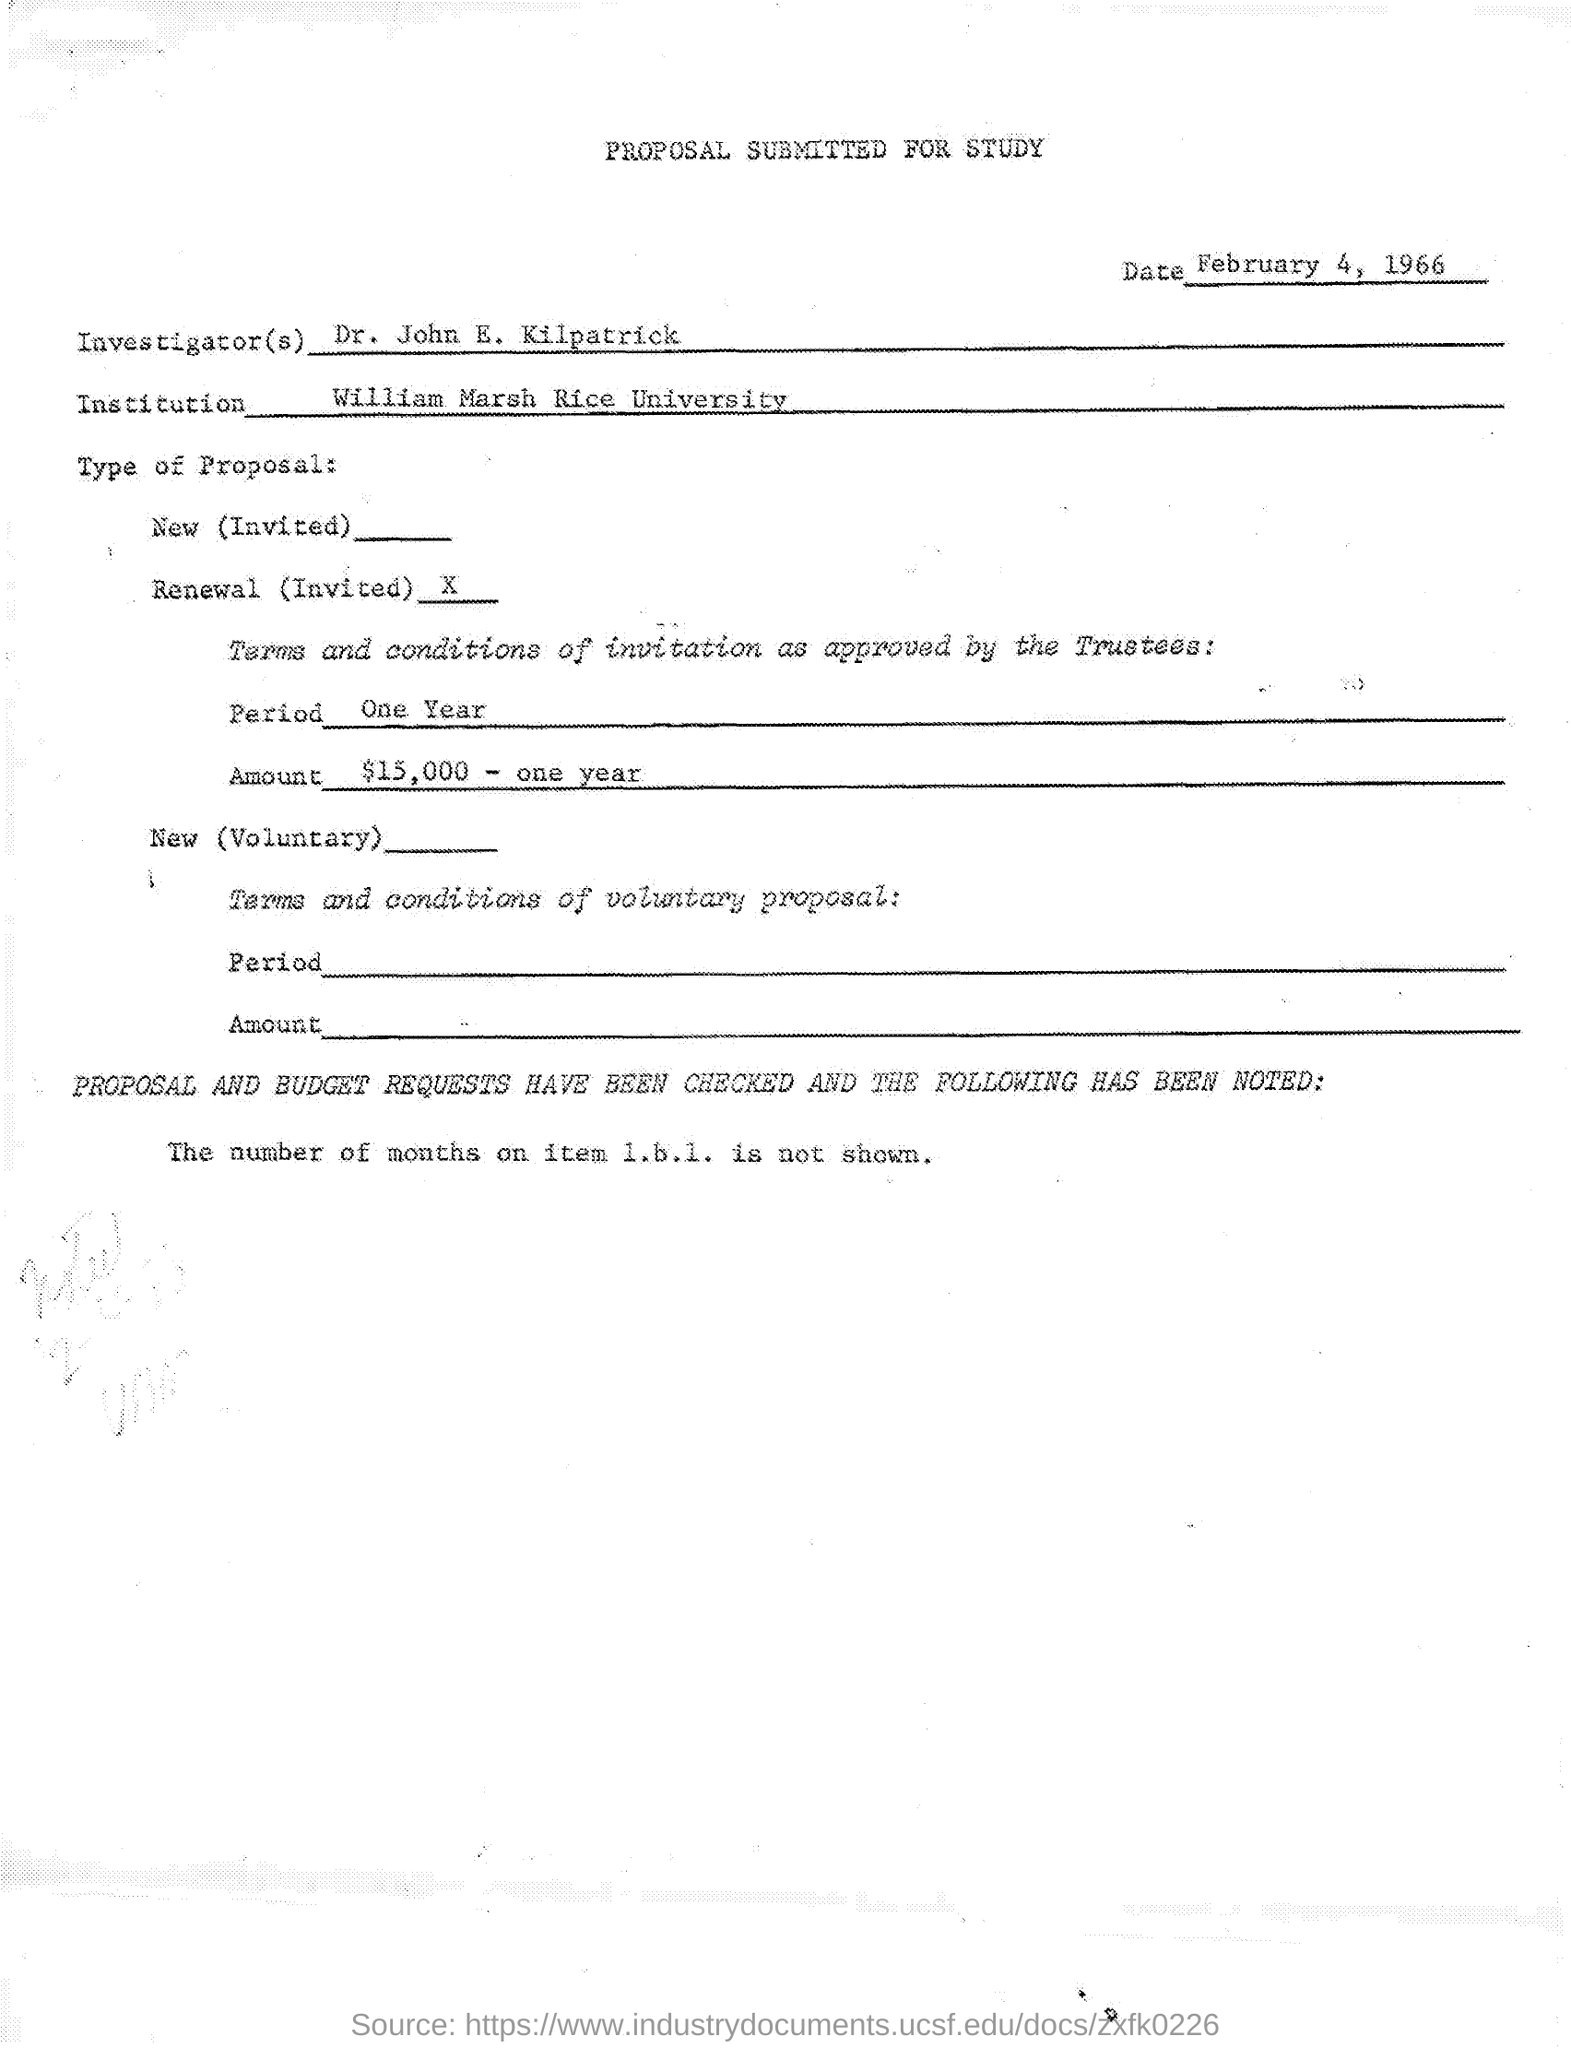What is the Date?
Ensure brevity in your answer.  February 4, 1966. Who is the Investigator?
Your answer should be very brief. Dr. John E. Kilpatrick. What is the Institution?
Your answer should be compact. William Marsh rice University. What is the Period?
Keep it short and to the point. One year. What is the Title of the Document?
Make the answer very short. Proposal Submitted for study. 